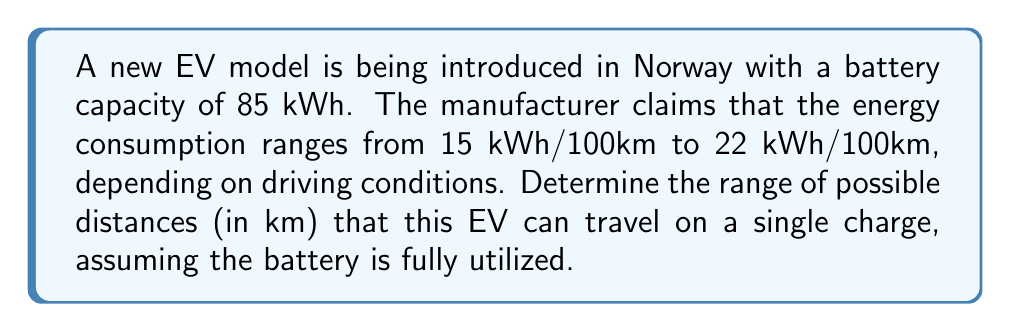Can you solve this math problem? Let's approach this step-by-step:

1) We need to find the minimum and maximum distances the EV can travel.

2) The formula for distance is:
   $$\text{Distance} = \frac{\text{Battery Capacity}}{\text{Energy Consumption per km}}$$

3) For the maximum distance:
   - Use the minimum energy consumption: 15 kWh/100km = 0.15 kWh/km
   $$\text{Max Distance} = \frac{85 \text{ kWh}}{0.15 \text{ kWh/km}} = 566.67 \text{ km}$$

4) For the minimum distance:
   - Use the maximum energy consumption: 22 kWh/100km = 0.22 kWh/km
   $$\text{Min Distance} = \frac{85 \text{ kWh}}{0.22 \text{ kWh/km}} = 386.36 \text{ km}$$

5) Therefore, the range of possible distances is from 386.36 km to 566.67 km.

6) Rounding to the nearest whole number for practical purposes:
   The range is from 386 km to 567 km.
Answer: $[386, 567]$ km 